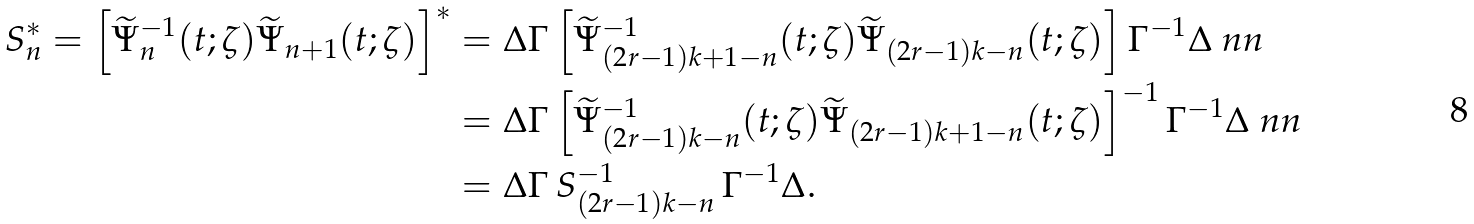<formula> <loc_0><loc_0><loc_500><loc_500>S _ { n } ^ { * } = \left [ \widetilde { \Psi } _ { n } ^ { - 1 } ( t ; \zeta ) \widetilde { \Psi } _ { n + 1 } ( t ; \zeta ) \right ] ^ { * } & = \Delta \Gamma \left [ \widetilde { \Psi } _ { ( 2 r - 1 ) k + 1 - n } ^ { - 1 } ( t ; \zeta ) \widetilde { \Psi } _ { ( 2 r - 1 ) k - n } ( t ; \zeta ) \right ] \Gamma ^ { - 1 } \Delta \ n n \\ & = \Delta \Gamma \left [ \widetilde { \Psi } _ { ( 2 r - 1 ) k - n } ^ { - 1 } ( t ; \zeta ) \widetilde { \Psi } _ { ( 2 r - 1 ) k + 1 - n } ( t ; \zeta ) \right ] ^ { - 1 } \Gamma ^ { - 1 } \Delta \ n n \\ & = \Delta \Gamma \, S _ { ( 2 r - 1 ) k - n } ^ { - 1 } \, \Gamma ^ { - 1 } \Delta .</formula> 